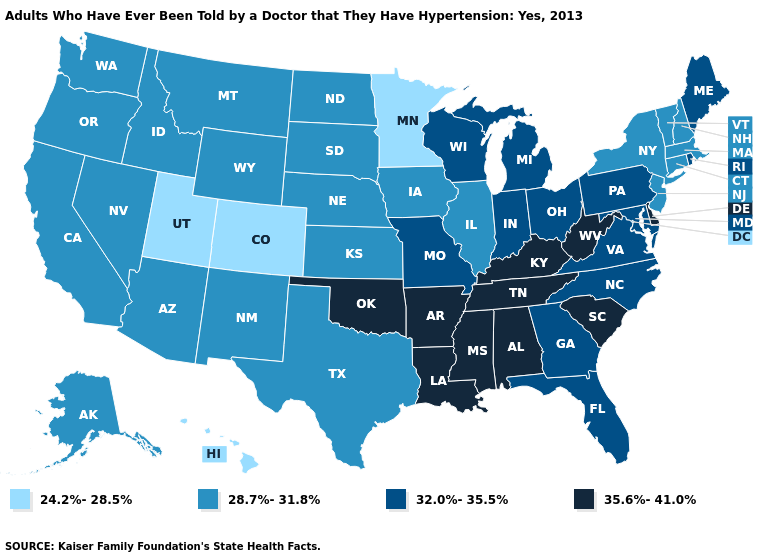Does Washington have the lowest value in the West?
Quick response, please. No. What is the highest value in the MidWest ?
Write a very short answer. 32.0%-35.5%. Name the states that have a value in the range 35.6%-41.0%?
Be succinct. Alabama, Arkansas, Delaware, Kentucky, Louisiana, Mississippi, Oklahoma, South Carolina, Tennessee, West Virginia. What is the highest value in the USA?
Short answer required. 35.6%-41.0%. What is the lowest value in states that border West Virginia?
Write a very short answer. 32.0%-35.5%. What is the value of Hawaii?
Answer briefly. 24.2%-28.5%. What is the highest value in states that border Colorado?
Write a very short answer. 35.6%-41.0%. Name the states that have a value in the range 28.7%-31.8%?
Write a very short answer. Alaska, Arizona, California, Connecticut, Idaho, Illinois, Iowa, Kansas, Massachusetts, Montana, Nebraska, Nevada, New Hampshire, New Jersey, New Mexico, New York, North Dakota, Oregon, South Dakota, Texas, Vermont, Washington, Wyoming. What is the highest value in states that border South Carolina?
Give a very brief answer. 32.0%-35.5%. What is the value of Wisconsin?
Short answer required. 32.0%-35.5%. Does Utah have the lowest value in the USA?
Quick response, please. Yes. What is the lowest value in states that border New Hampshire?
Quick response, please. 28.7%-31.8%. Does West Virginia have the highest value in the South?
Write a very short answer. Yes. Name the states that have a value in the range 35.6%-41.0%?
Answer briefly. Alabama, Arkansas, Delaware, Kentucky, Louisiana, Mississippi, Oklahoma, South Carolina, Tennessee, West Virginia. What is the value of South Carolina?
Concise answer only. 35.6%-41.0%. 